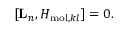<formula> <loc_0><loc_0><loc_500><loc_500>[ { L } _ { n } , H _ { m o l , k l } ] = 0 .</formula> 